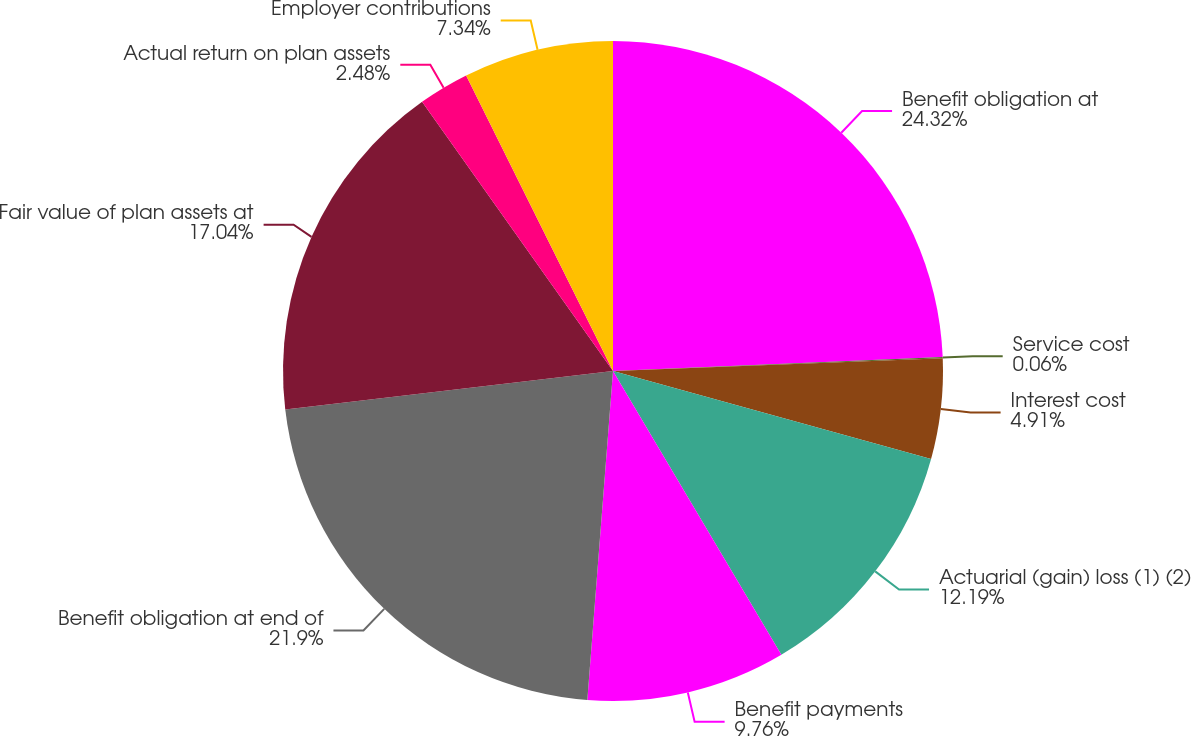<chart> <loc_0><loc_0><loc_500><loc_500><pie_chart><fcel>Benefit obligation at<fcel>Service cost<fcel>Interest cost<fcel>Actuarial (gain) loss (1) (2)<fcel>Benefit payments<fcel>Benefit obligation at end of<fcel>Fair value of plan assets at<fcel>Actual return on plan assets<fcel>Employer contributions<nl><fcel>24.32%<fcel>0.06%<fcel>4.91%<fcel>12.19%<fcel>9.76%<fcel>21.9%<fcel>17.04%<fcel>2.48%<fcel>7.34%<nl></chart> 